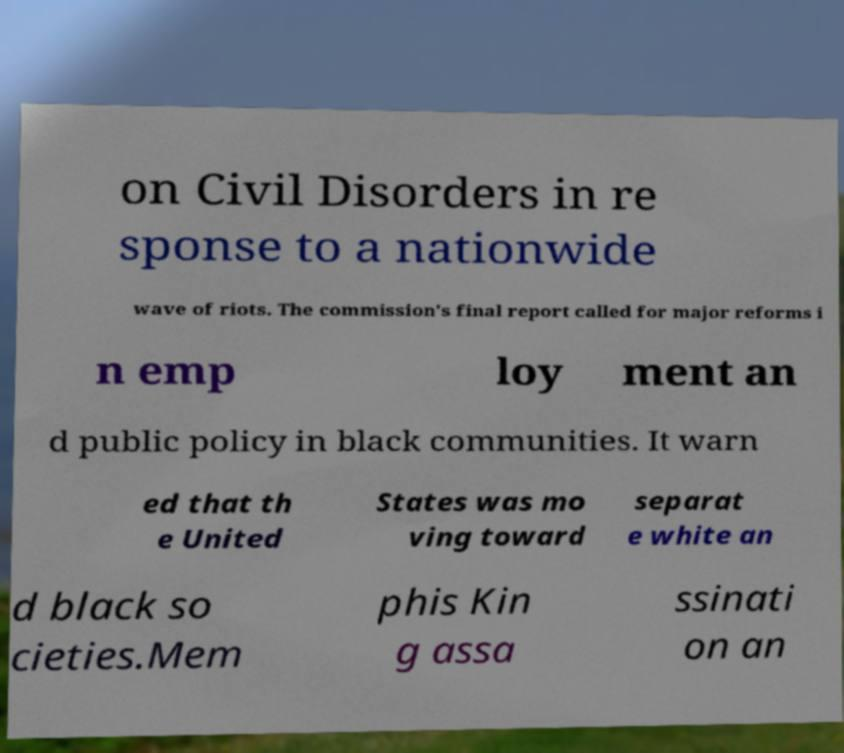Please identify and transcribe the text found in this image. on Civil Disorders in re sponse to a nationwide wave of riots. The commission's final report called for major reforms i n emp loy ment an d public policy in black communities. It warn ed that th e United States was mo ving toward separat e white an d black so cieties.Mem phis Kin g assa ssinati on an 